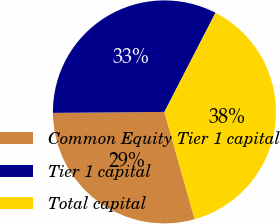Convert chart to OTSL. <chart><loc_0><loc_0><loc_500><loc_500><pie_chart><fcel>Common Equity Tier 1 capital<fcel>Tier 1 capital<fcel>Total capital<nl><fcel>29.23%<fcel>32.71%<fcel>38.05%<nl></chart> 